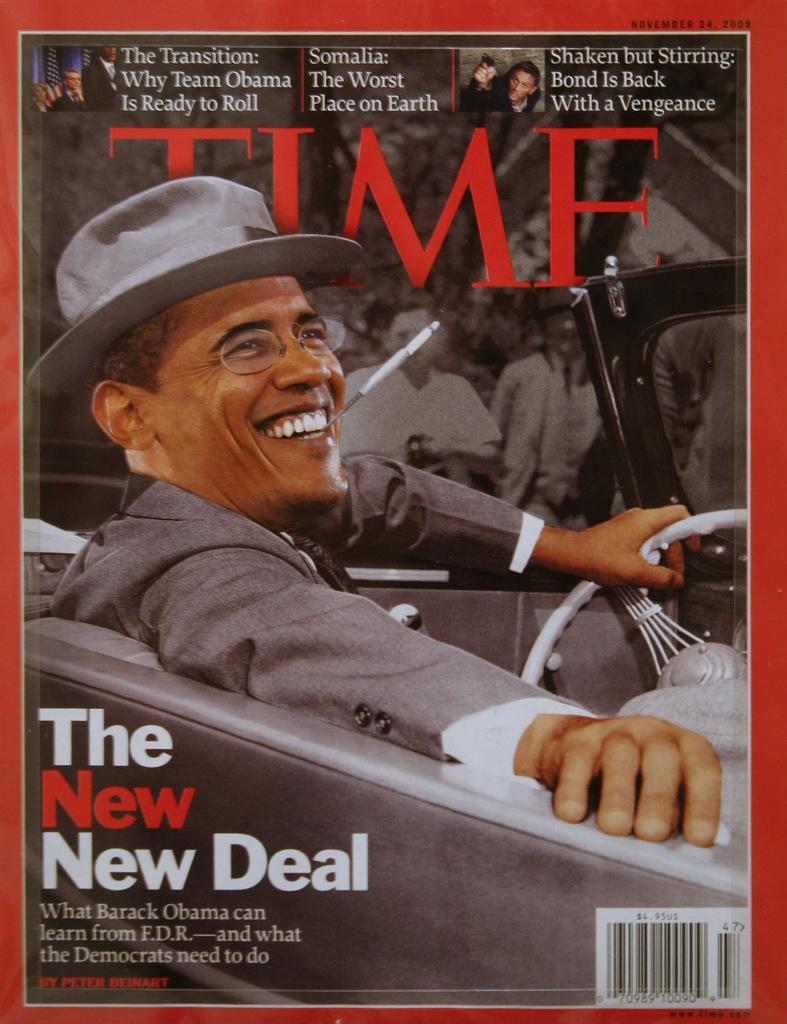Provide a one-sentence caption for the provided image. Time magazine with Barack Obama on the cover. 